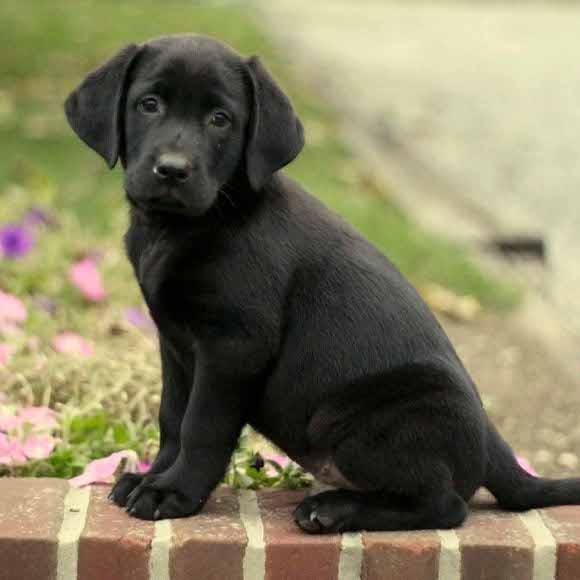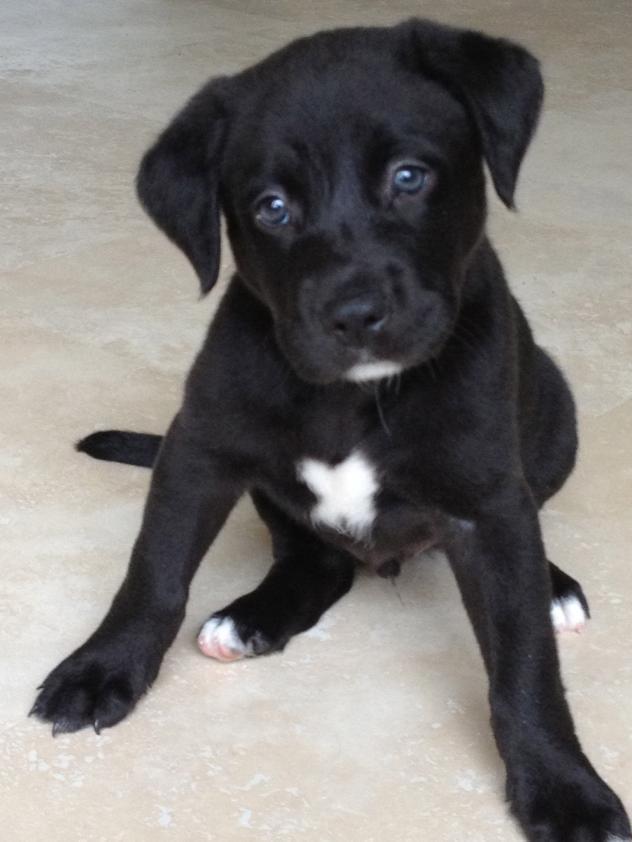The first image is the image on the left, the second image is the image on the right. For the images shown, is this caption "Each image shows a black lab pup in a sitting pose." true? Answer yes or no. Yes. The first image is the image on the left, the second image is the image on the right. Considering the images on both sides, is "there is a puppy with tags on it's collar" valid? Answer yes or no. No. 